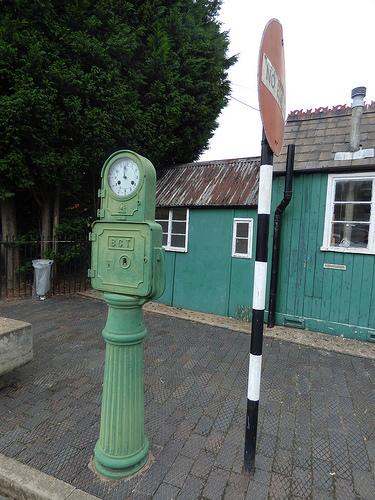<image>
Can you confirm if the pole is in front of the clock? No. The pole is not in front of the clock. The spatial positioning shows a different relationship between these objects. 